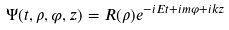Convert formula to latex. <formula><loc_0><loc_0><loc_500><loc_500>\Psi ( t , \rho , \varphi , z ) = R ( \rho ) e ^ { - i E t + i m \varphi + i k z }</formula> 